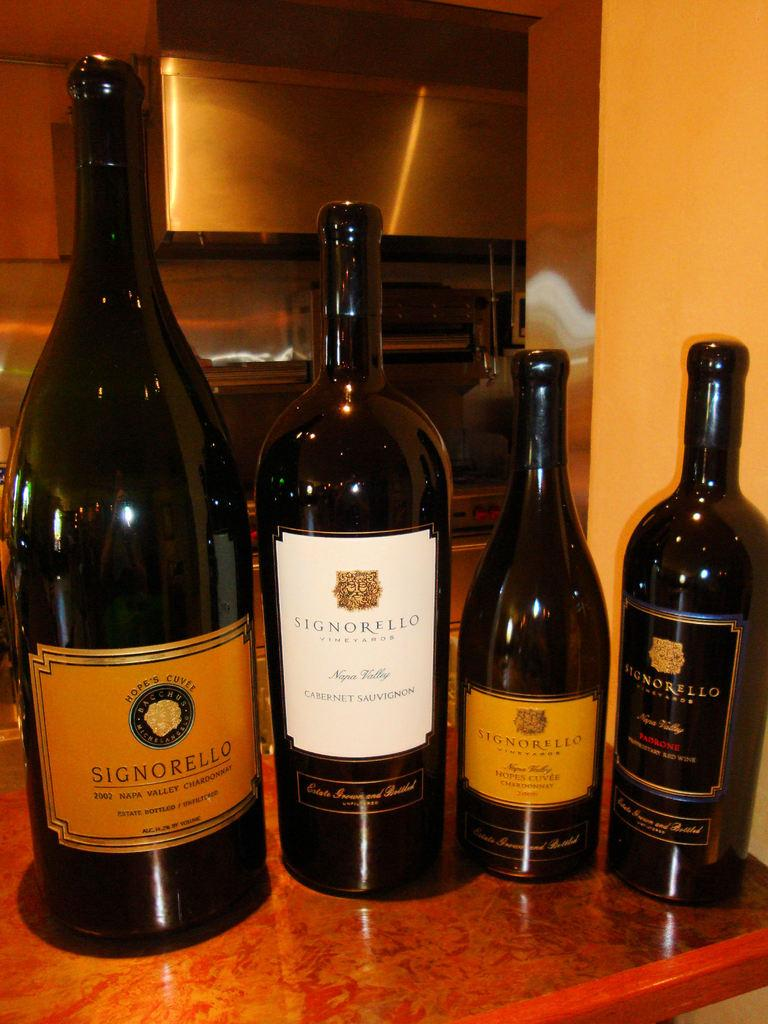What type of location is depicted in the image? The image shows an inside view of a room. What objects can be seen on the table in the image? There are four bottles on the table in the image. What feature do the bottles have in common? The bottles have labels. What information is provided on the labels? The labels contain text. How many mice are hiding under the table in the image? There is no indication of mice in the image; it only shows four bottles on a table with labeled text. 